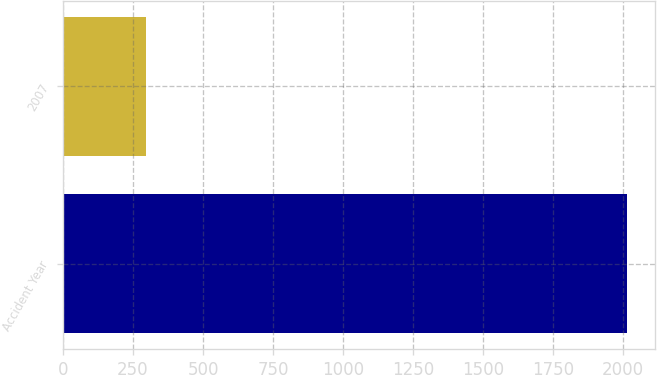Convert chart to OTSL. <chart><loc_0><loc_0><loc_500><loc_500><bar_chart><fcel>Accident Year<fcel>2007<nl><fcel>2013<fcel>295<nl></chart> 